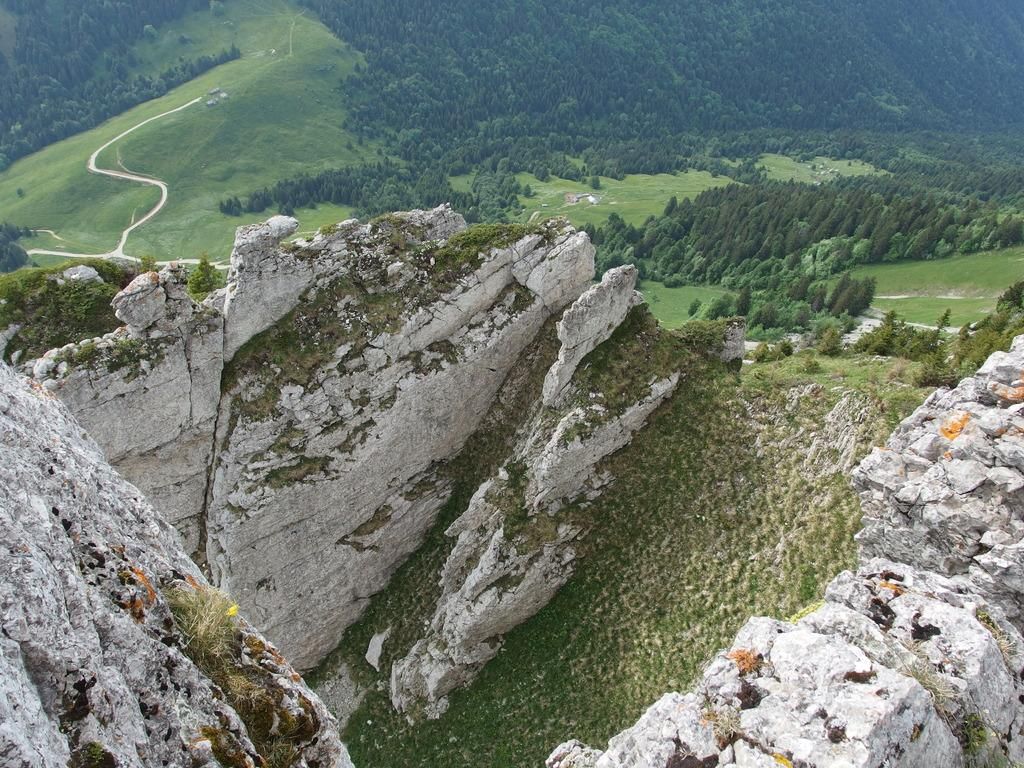What is the location of the image? The image is captured from a hill station. What can be observed in terms of vegetation in the image? There is beautiful greenery, a lot of grass, and plenty of trees in the image. What type of lunch is being served in the image? There is no lunch or any indication of food in the image; it primarily features greenery and trees. 